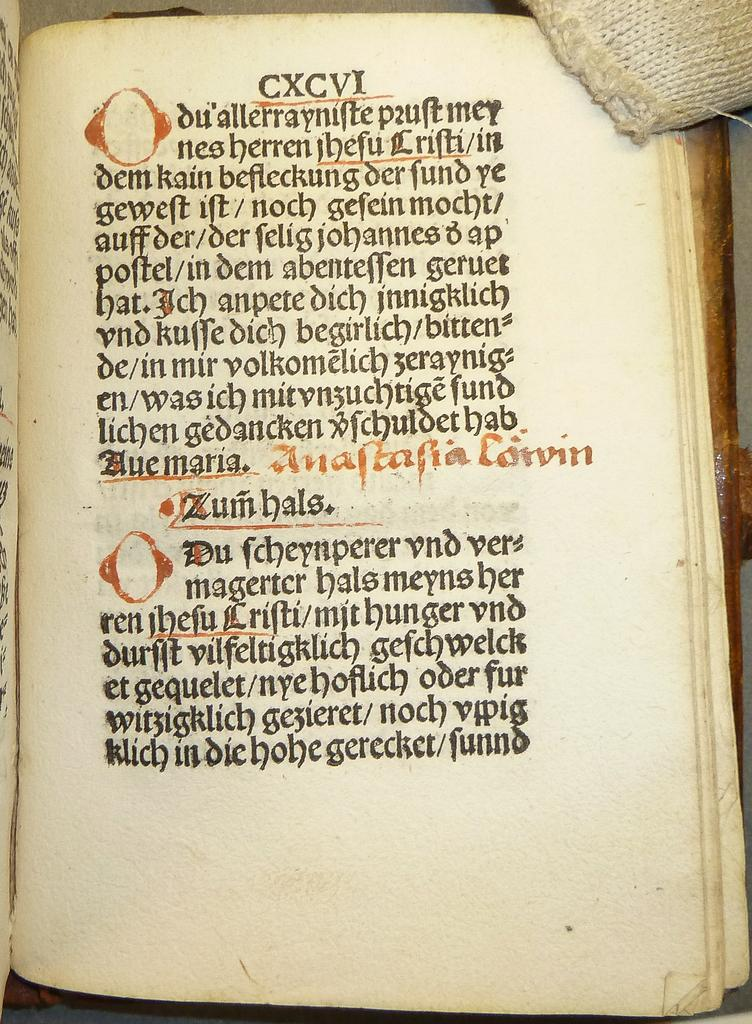What is the main object in the image? There is a book in the image. What can be found on the book? There is text on the book. Can you describe the object in the top right-hand corner of the image? Unfortunately, the provided facts do not give any information about the object in the top right-hand corner of the image. What type of comb is used to create the thunder sound in the image? There is no comb or thunder sound present in the image. 